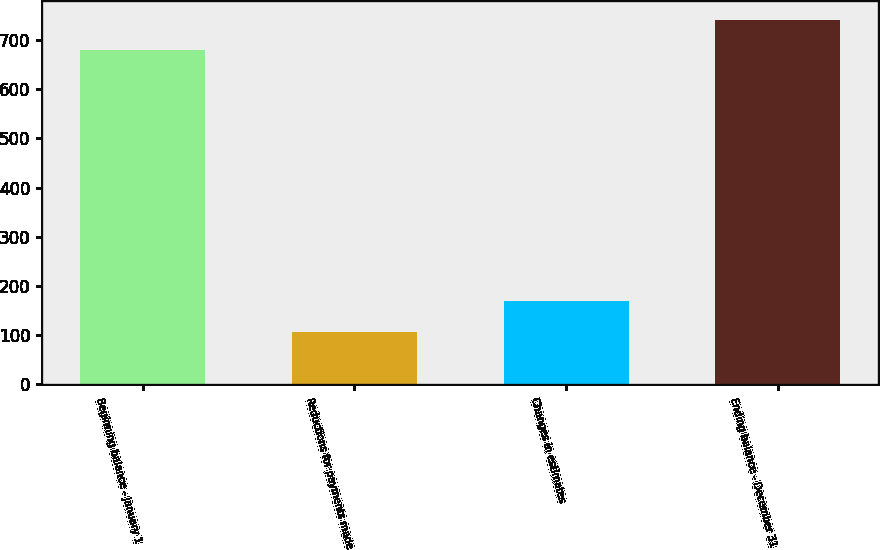Convert chart. <chart><loc_0><loc_0><loc_500><loc_500><bar_chart><fcel>Beginning balance - January 1<fcel>Reductions for payments made<fcel>Changes in estimates<fcel>Ending balance - December 31<nl><fcel>679<fcel>106<fcel>168.5<fcel>741.5<nl></chart> 